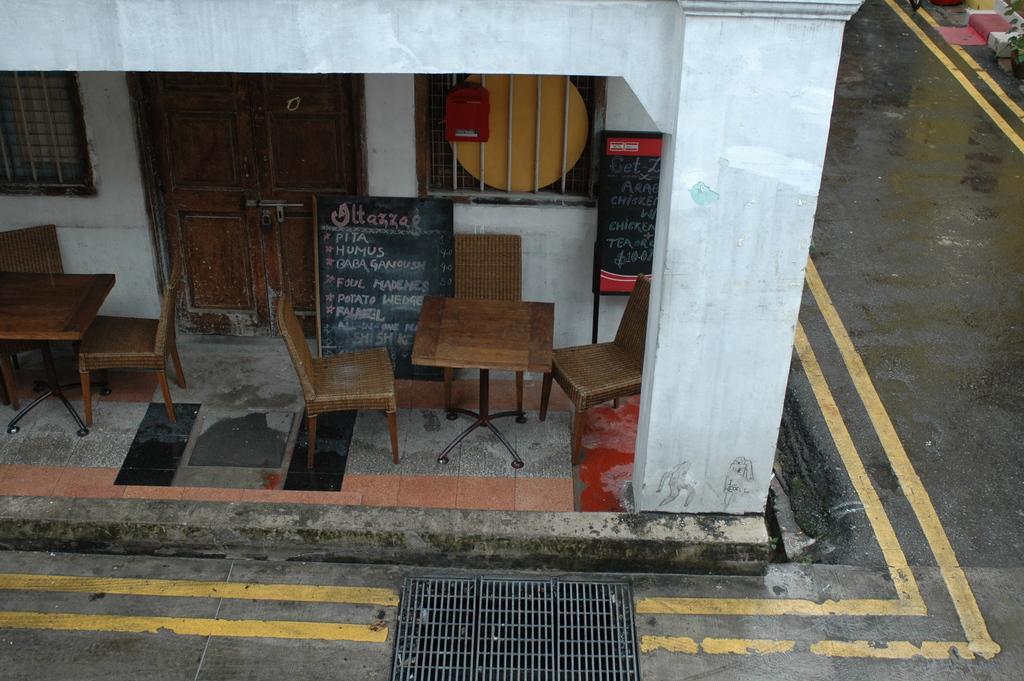Can you describe this image briefly? These are the wooden chairs and tables in front of this house and on the right side it is road. 